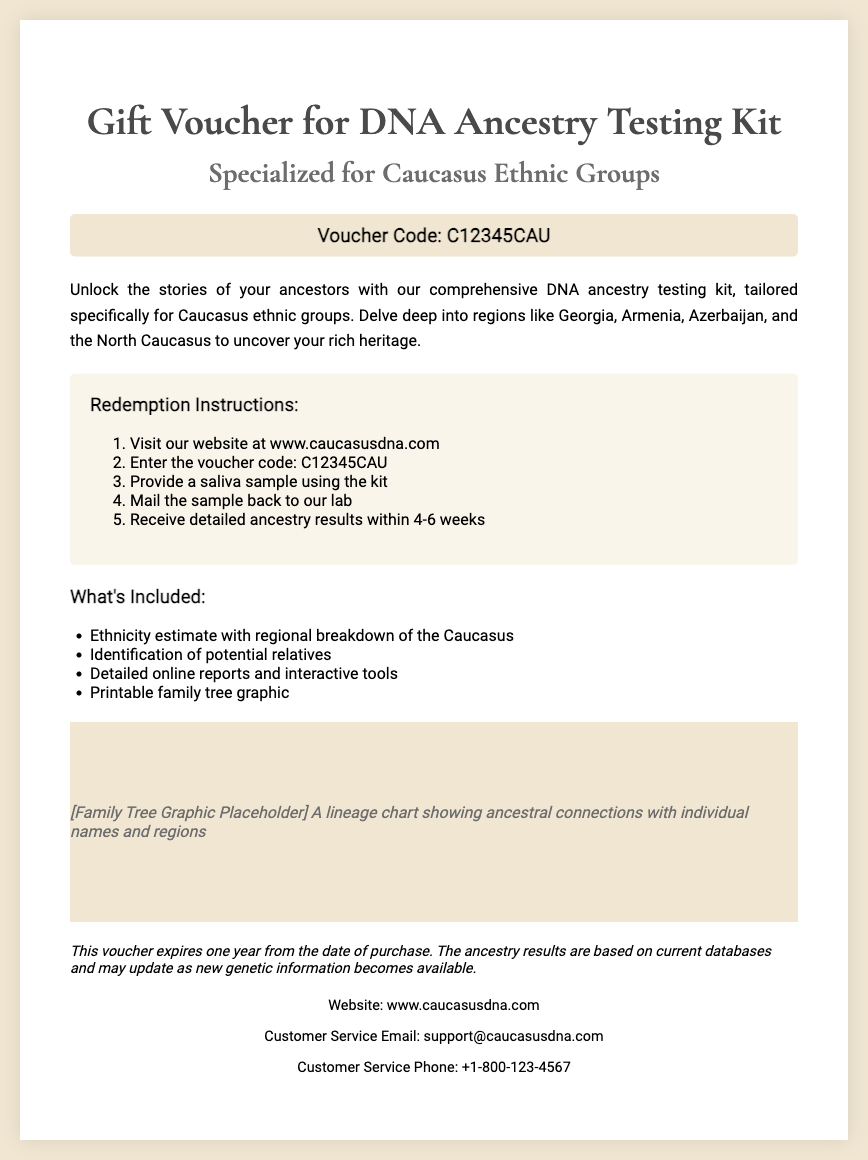What is the voucher code? The voucher code is mentioned prominently in the document for redemption purposes.
Answer: C12345CAU What website should I visit to redeem the voucher? The redemption instructions provide a specific website for users to visit.
Answer: www.caucasusdna.com How long will it take to receive the ancestry results? The document states the expected time frame for receiving results after sending the sample.
Answer: 4-6 weeks What ethnic regions are mentioned in the voucher? The ethnic regions are specifically listed in the description to highlight target groups for the testing kit.
Answer: Georgia, Armenia, Azerbaijan, North Caucasus What is included in the ancestry testing kit? The details section outlines the contents and services provided with the kit.
Answer: Ethnicity estimate, identification of potential relatives, detailed online reports, printable family tree graphic What does the family tree graphic represent? The family tree graphic serves a specific function in the context of the ancestry testing service provided.
Answer: A lineage chart showing ancestral connections with individual names and regions When does this voucher expire? The document includes a specific time frame for voucher validity.
Answer: One year from the date of purchase What is the customer service email address? The contact information section provides the customer service email for inquiries.
Answer: support@caucasusdna.com 